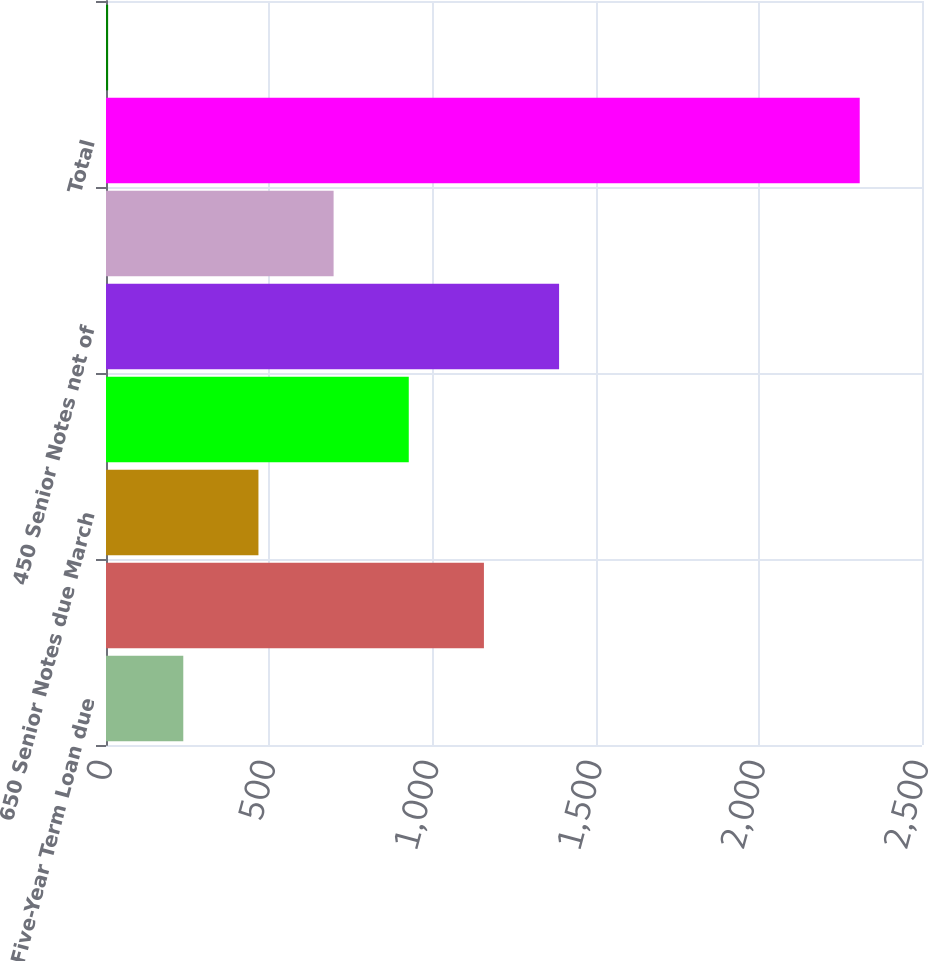Convert chart to OTSL. <chart><loc_0><loc_0><loc_500><loc_500><bar_chart><fcel>Five-Year Term Loan due<fcel>Seven-Year Term Loan due<fcel>650 Senior Notes due March<fcel>390 Senior Notes net of<fcel>450 Senior Notes net of<fcel>365 Senior Notes net of<fcel>Total<fcel>Less current portion<nl><fcel>236.77<fcel>1157.85<fcel>467.04<fcel>927.58<fcel>1388.12<fcel>697.31<fcel>2309.2<fcel>6.5<nl></chart> 